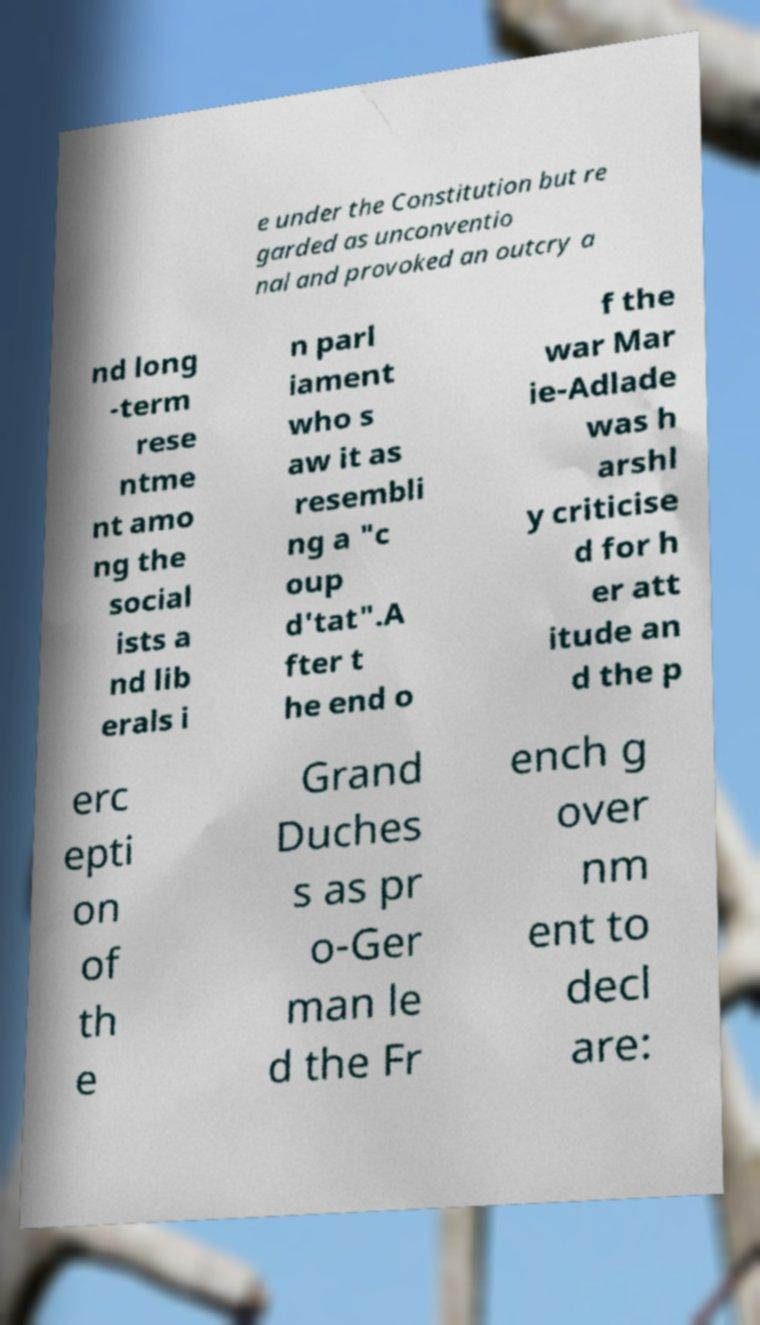Please read and relay the text visible in this image. What does it say? e under the Constitution but re garded as unconventio nal and provoked an outcry a nd long -term rese ntme nt amo ng the social ists a nd lib erals i n parl iament who s aw it as resembli ng a "c oup d'tat".A fter t he end o f the war Mar ie-Adlade was h arshl y criticise d for h er att itude an d the p erc epti on of th e Grand Duches s as pr o-Ger man le d the Fr ench g over nm ent to decl are: 